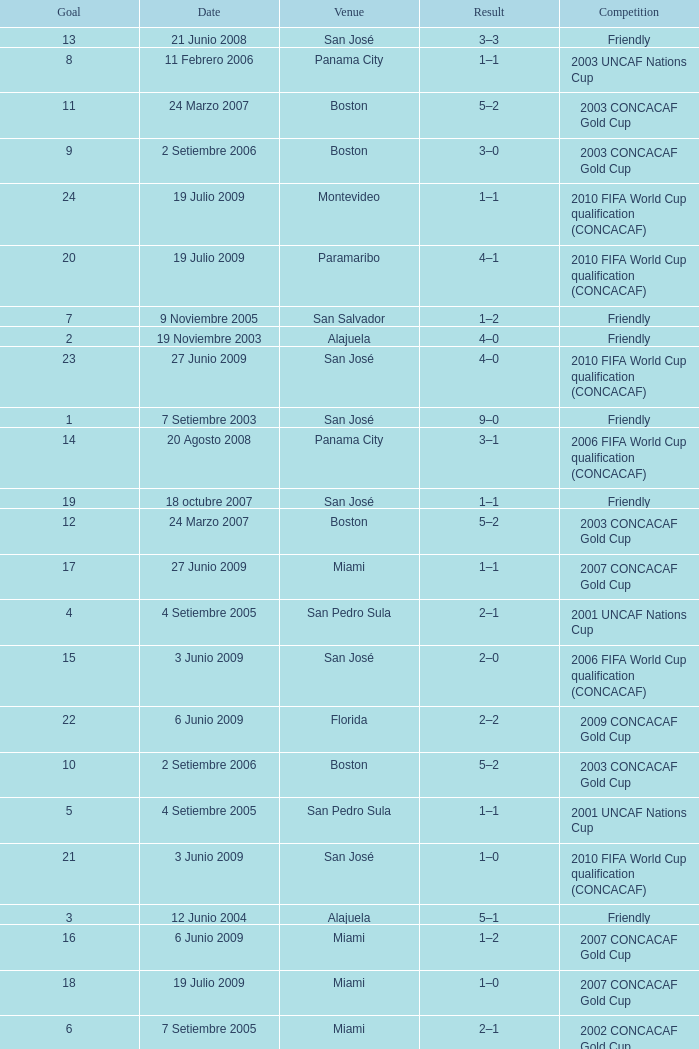How was the competition in which 6 goals were made? 2002 CONCACAF Gold Cup. 